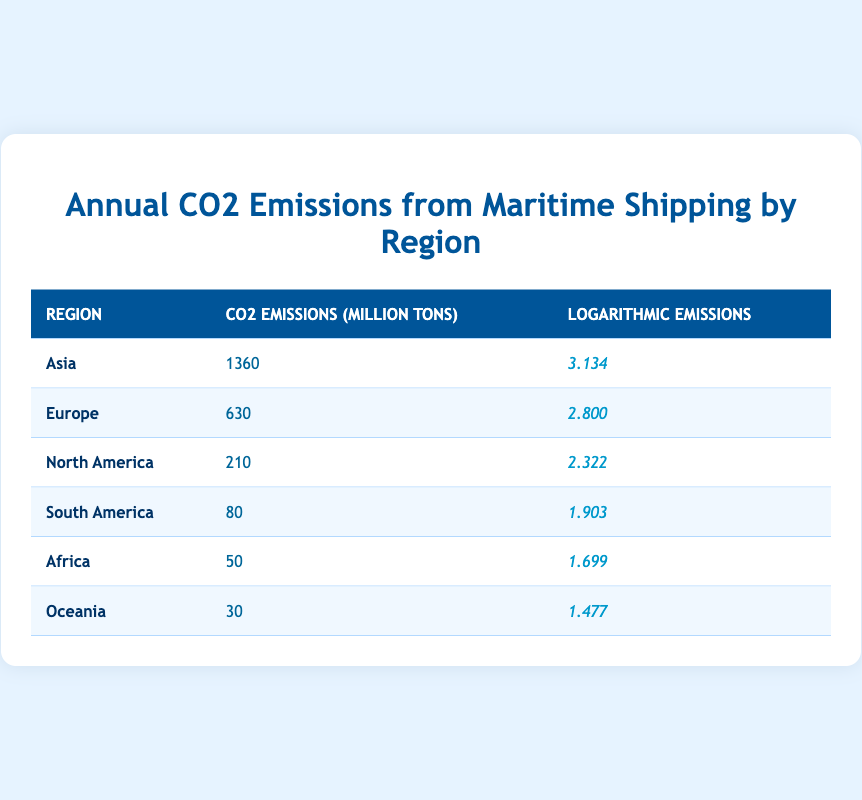What region has the highest annual CO2 emissions from maritime shipping? The table lists the CO2 emissions by region, and Asia shows the highest value at 1360 million tons.
Answer: Asia What is the CO2 emission value for Europe? Referring directly to the table, Europe has CO2 emissions of 630 million tons.
Answer: 630 million tons What is the difference in CO2 emissions between Asia and North America? Asia has 1360 million tons, and North America has 210 million tons. Subtracting gives 1360 - 210 = 1150 million tons; therefore, the difference is 1150 million tons.
Answer: 1150 million tons Are CO2 emissions from Oceania greater than those from Africa? Oceania has emissions of 30 million tons, while Africa has 50 million tons. Since 30 is not greater than 50, the answer is no.
Answer: No What is the total CO2 emissions from South America, Africa, and Oceania combined? The emissions for each region are 80 (South America), 50 (Africa), and 30 (Oceania). Adding these together gives 80 + 50 + 30 = 160 million tons.
Answer: 160 million tons What region has the lowest logarithmic emissions value? Checking the logarithmic emissions shown in the table, Oceania has the lowest value at 1.477.
Answer: Oceania What is the average annual CO2 emissions from all regions listed in the table? First, sum all the emissions: 1360 + 630 + 210 + 80 + 50 + 30 = 2360 million tons. There are 6 regions, so dividing gives 2360 / 6 ≈ 393.33 million tons.
Answer: 393.33 million tons Is it true that Europe has higher CO2 emissions than South America? Europe has 630 million tons, while South America has 80 million tons. Since 630 is greater than 80, the statement is true.
Answer: Yes Which region has logarithmic emissions greater than 3? Looking at the logarithmic emissions, only Asia has a value of 3.134 which is greater than 3.
Answer: Asia 